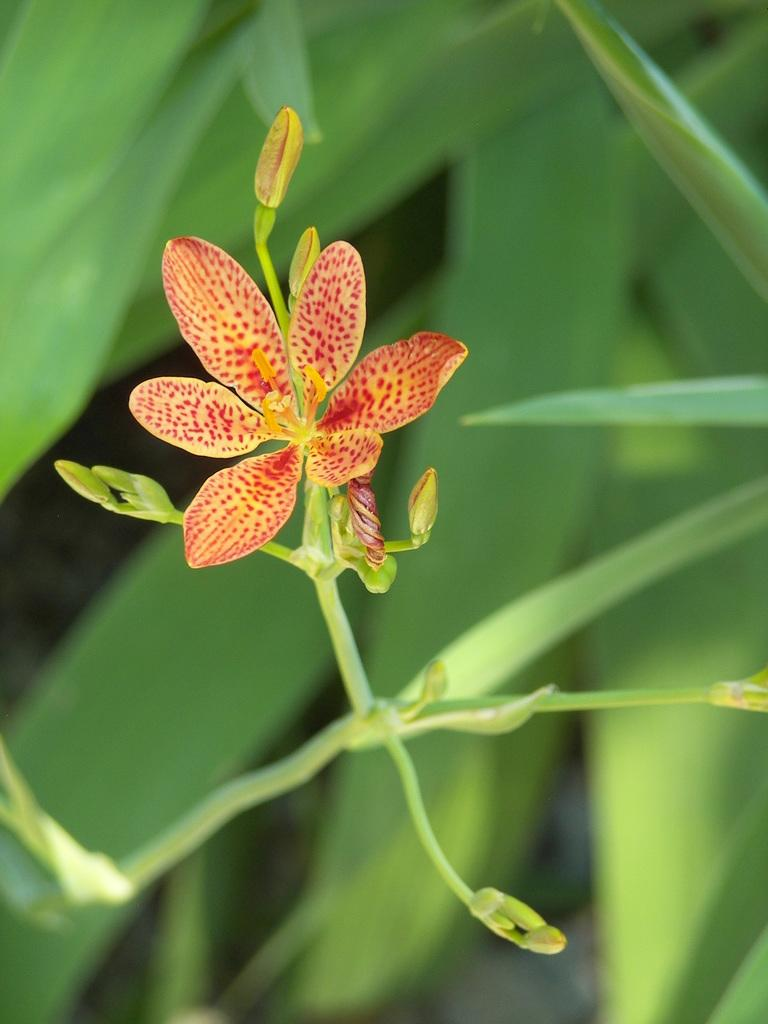What is present in the image? There is a plant in the image. Can you describe the plant in more detail? The plant has a flower. How many bears can be seen walking on the trail in the image? There is no trail or bears present in the image; it features a plant with a flower. 